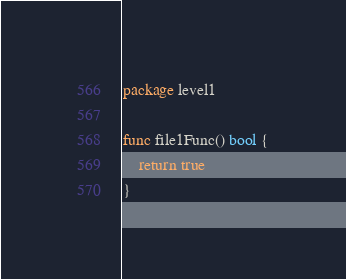<code> <loc_0><loc_0><loc_500><loc_500><_Go_>package level1

func file1Func() bool {
	return true
}
</code> 